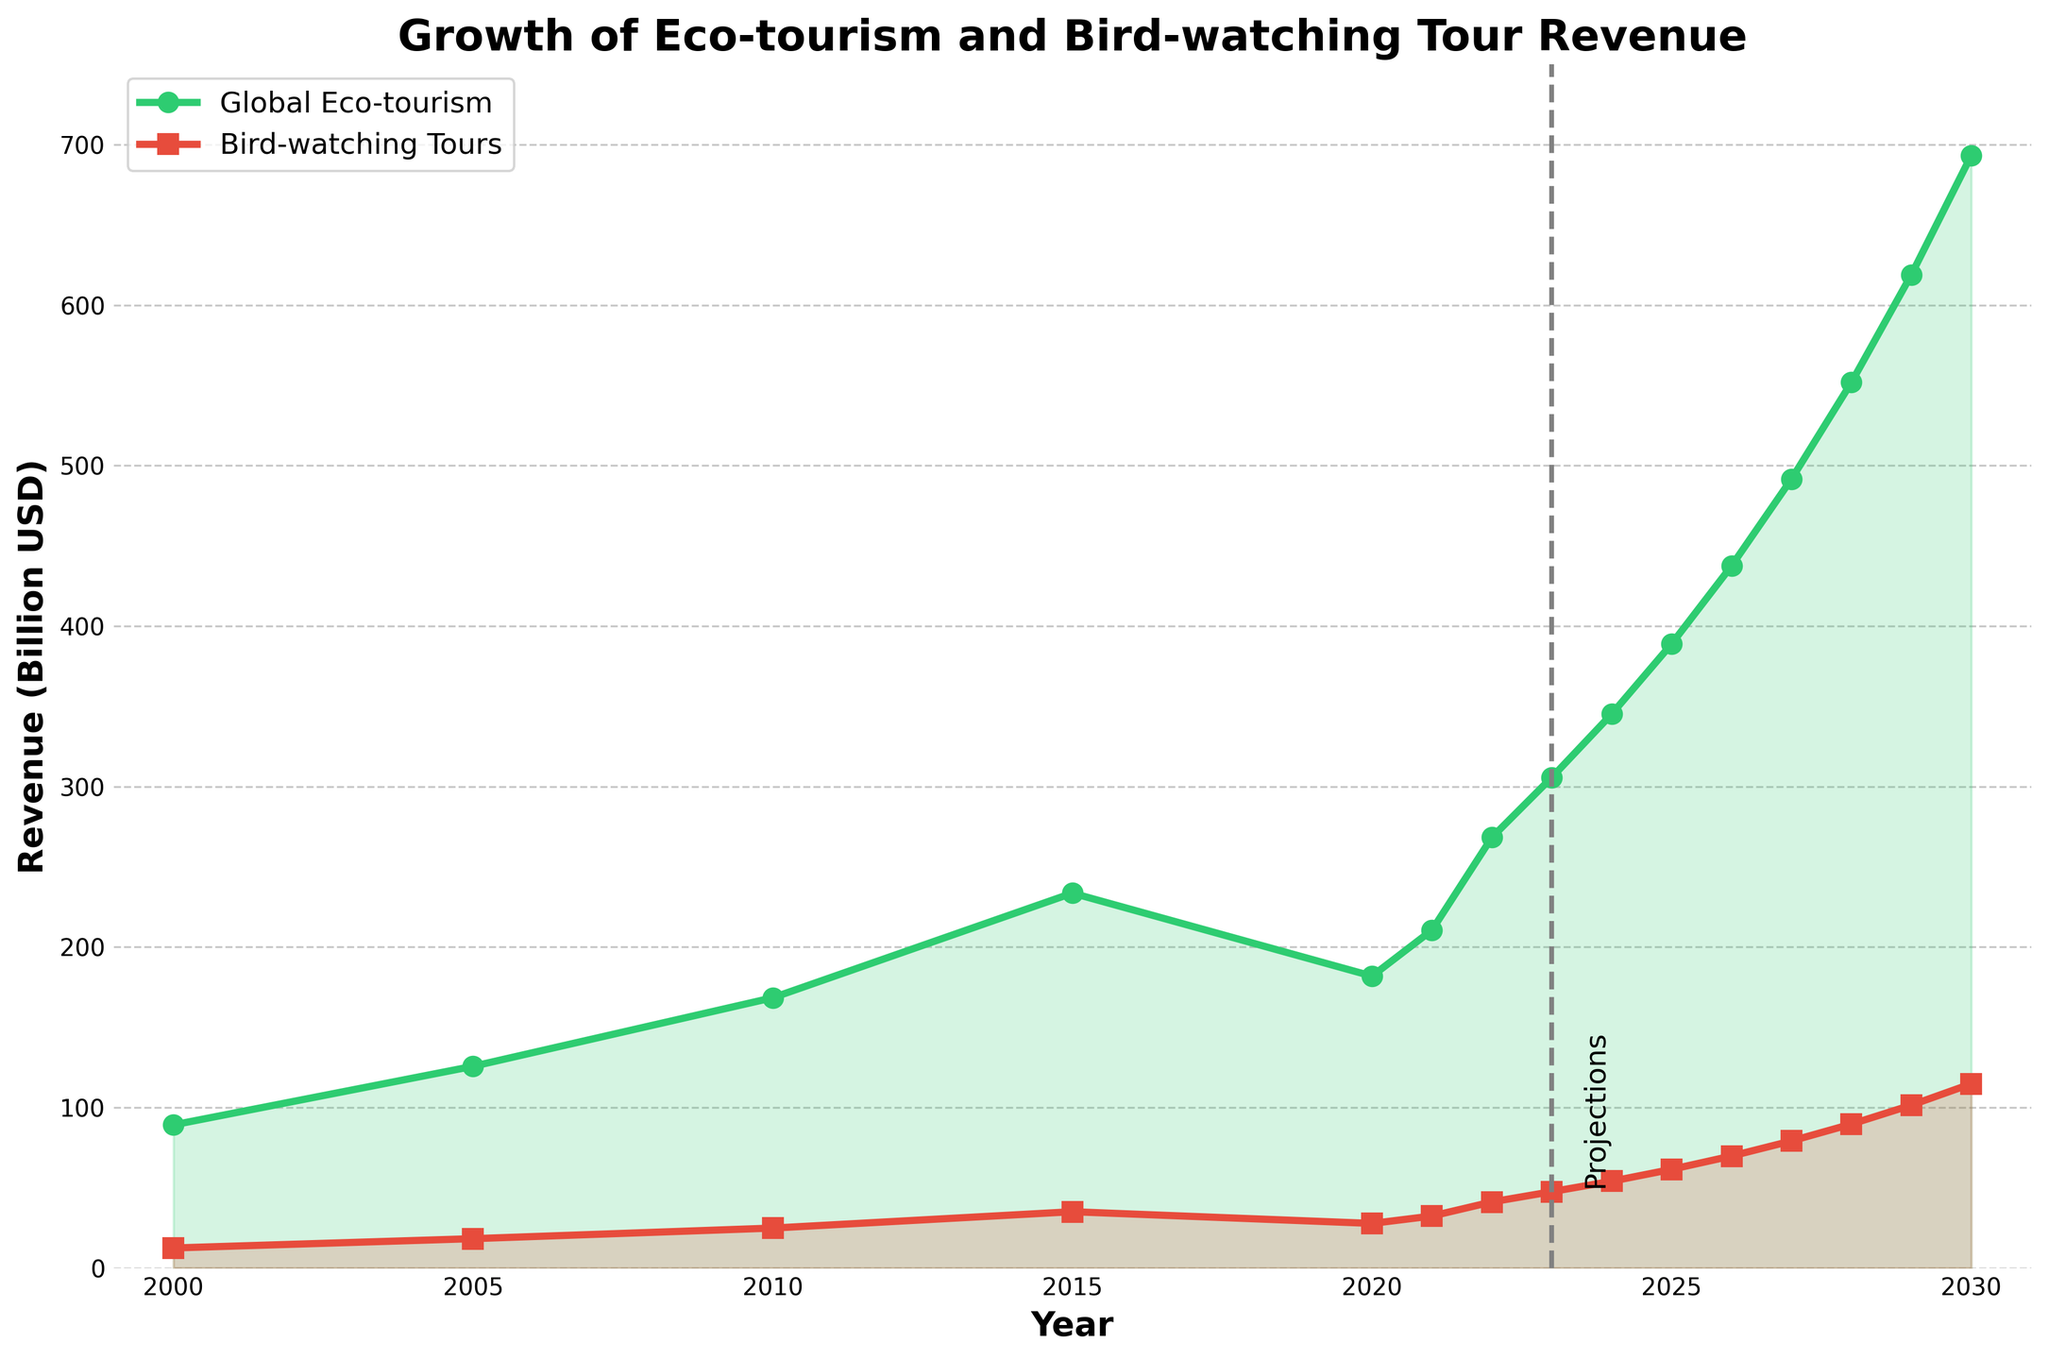What is the revenue from bird-watching tours projected to be in 2025? To determine the projected revenue from bird-watching tours in 2025, locate the year 2025 on the x-axis and then find the corresponding value for the Bird-watching Tour Revenue (orange line).
Answer: 61.5 Billion USD What is the difference in global eco-tourism revenue between 2000 and 2023? To find the difference in revenue between 2000 and 2023, subtract the value in 2000 (89.2 Billion USD) from the value in 2023 (305.7 Billion USD). Difference = 305.7 - 89.2.
Answer: 216.5 Billion USD By what year is the global eco-tourism revenue expected to exceed 500 Billion USD? Locate the green line on the plot for the Global Eco-tourism Revenue and find the year where it first crosses above 500 Billion USD. This happens in 2028.
Answer: 2028 How does the projected revenue growth for bird-watching tours between 2023 and 2030 compare to that from 2010 to 2017? Calculate the difference in revenue for each period. From 2023 to 2030: 114.8 - 47.6 = 67.2 Billion USD. For 2010 to 2017, we look at data points, but the exact value for 2017 isn't provided. We use 2015 and 2021 as a rough range: 32.4 - 24.9 = 7.5 Billion USD between closest years.
Answer: 2023-2030 growth (67.2 Billion USD) is significantly higher than 2010-2015 based on given data What year experienced the lowest bird-watching tour revenue, and what was the revenue? Scan the orange line and look for the lowest point up to 2023. The minimum is at the year 2000 with a revenue of 12.5 Billion USD.
Answer: 2000, 12.5 Billion USD In 2020, what is the percentage decrease in global eco-tourism revenue from the previous year (2019)? Assuming linear interpolation for simplicity, first estimate the value of 2020's revenue decline. From 2015 to 2021, a decrease in 2020 can be noticed. Use (233.6 Billion in 2015 and 210.5 in 2021) as guidance.
Answer: (233.6 - 181.9) / 233.6 * 100% What is the relationship between global eco-tourism revenue and bird-watching tour revenue post-2023? Evaluate the two plotted lines after 2023. Both lines show a positive slope, indicating they are both projected to increase. However, the green line (eco-tourism) grows at a higher rate.
Answer: Both are increasing with eco-tourism growing faster What does the vertical dashed line in the middle of the chart represent? The dashed line at year 2023 marks the point where past data ends and future projections begin, as labeled "Projections."
Answer: Start of projections Which year shows the largest year-over-year increase in bird-watching tour revenue, according to the projections? Look at the steepness of the orange line in the projection area (post-2023). Compare the differences year to year. The steepest increase appears between 2029 and 2030: 114.8 - 101.5 = 13.3 Billion USD increase.
Answer: 2029-2030 Between 2000 and 2023, how many years show a decline in global eco-tourism revenue? Examine the green line and note the years where it dips. The notable year is 2020 due to pandemic impact.
Answer: 1 year 